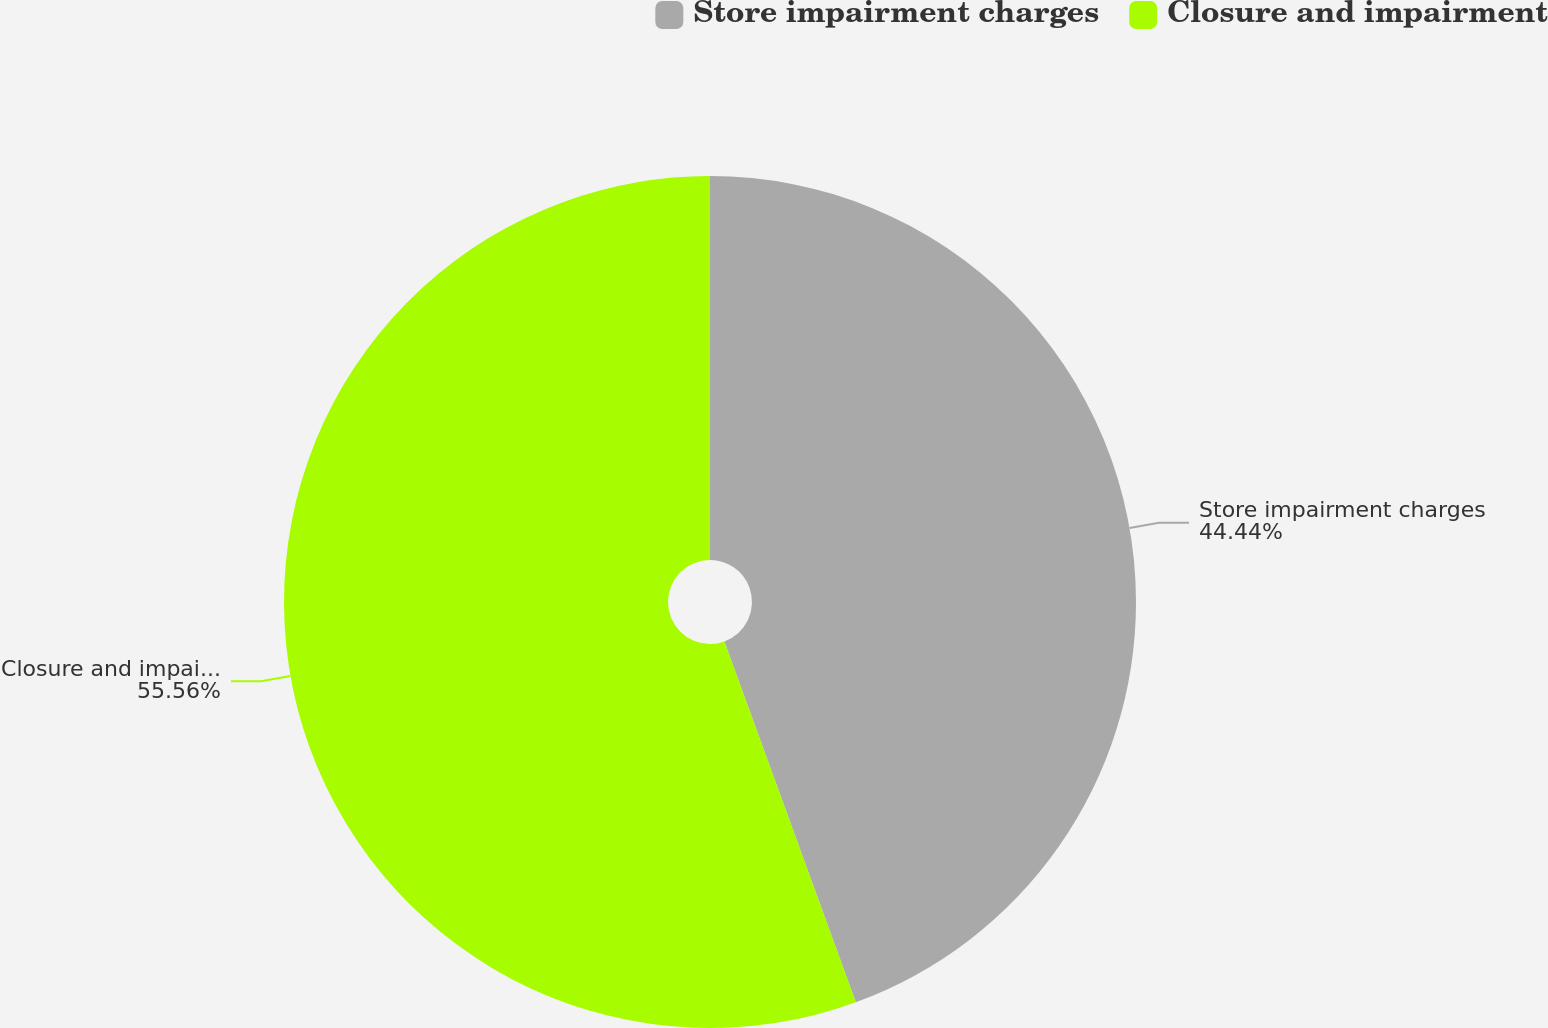Convert chart to OTSL. <chart><loc_0><loc_0><loc_500><loc_500><pie_chart><fcel>Store impairment charges<fcel>Closure and impairment<nl><fcel>44.44%<fcel>55.56%<nl></chart> 